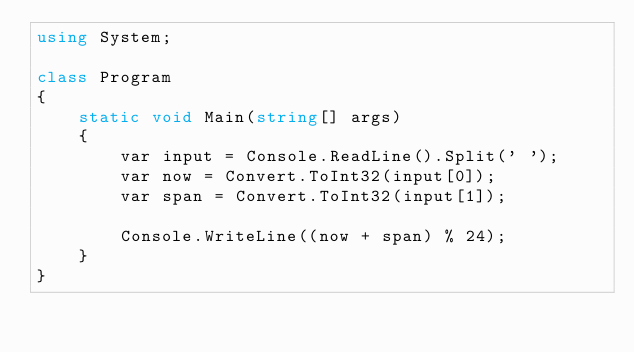Convert code to text. <code><loc_0><loc_0><loc_500><loc_500><_C#_>using System;

class Program
{
    static void Main(string[] args)
    {
        var input = Console.ReadLine().Split(' ');
        var now = Convert.ToInt32(input[0]);
        var span = Convert.ToInt32(input[1]);

        Console.WriteLine((now + span) % 24);
    }
}</code> 